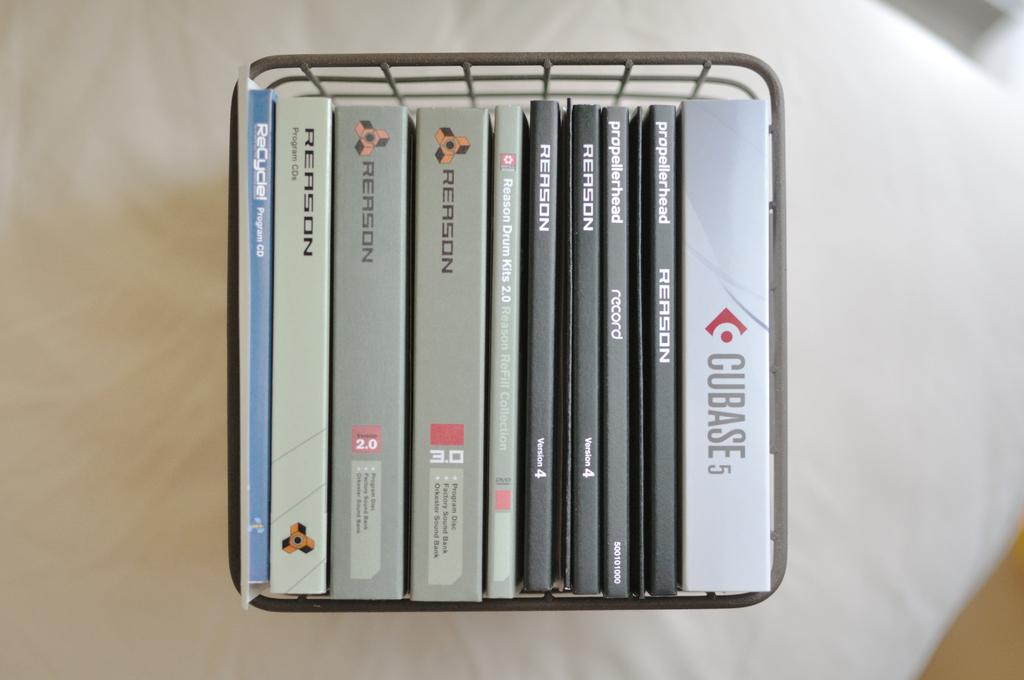What is the text on the far right before the 5?
Provide a short and direct response. Cubase. 